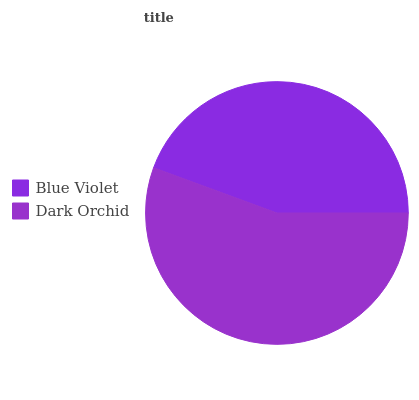Is Blue Violet the minimum?
Answer yes or no. Yes. Is Dark Orchid the maximum?
Answer yes or no. Yes. Is Dark Orchid the minimum?
Answer yes or no. No. Is Dark Orchid greater than Blue Violet?
Answer yes or no. Yes. Is Blue Violet less than Dark Orchid?
Answer yes or no. Yes. Is Blue Violet greater than Dark Orchid?
Answer yes or no. No. Is Dark Orchid less than Blue Violet?
Answer yes or no. No. Is Dark Orchid the high median?
Answer yes or no. Yes. Is Blue Violet the low median?
Answer yes or no. Yes. Is Blue Violet the high median?
Answer yes or no. No. Is Dark Orchid the low median?
Answer yes or no. No. 